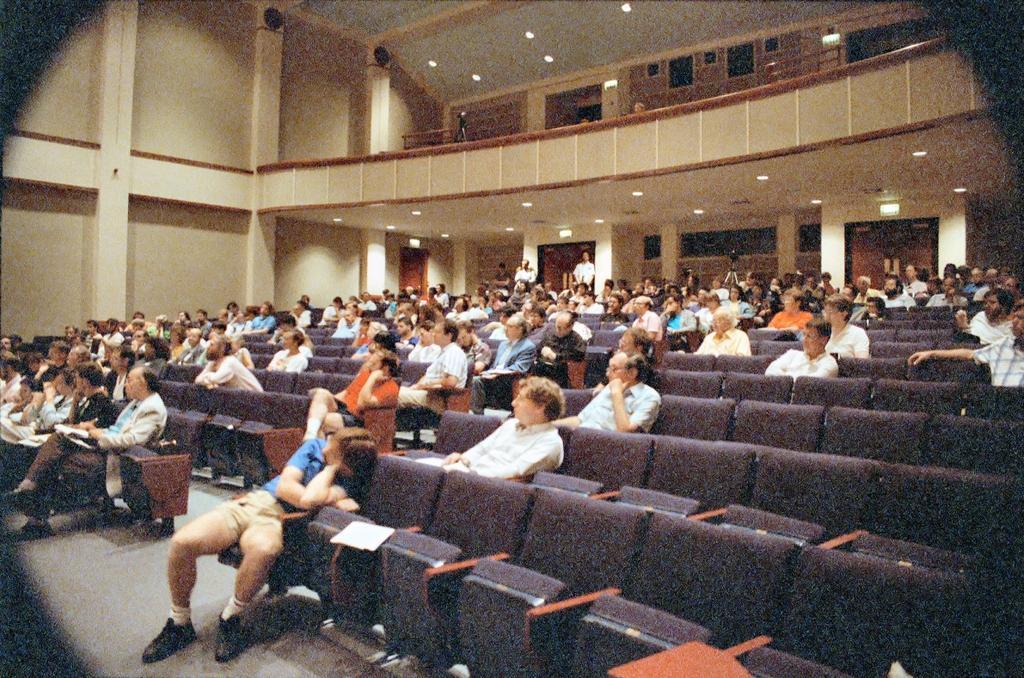Please provide a concise description of this image. As we can see in the image there is a wall and few people sitting here and there on chairs. 